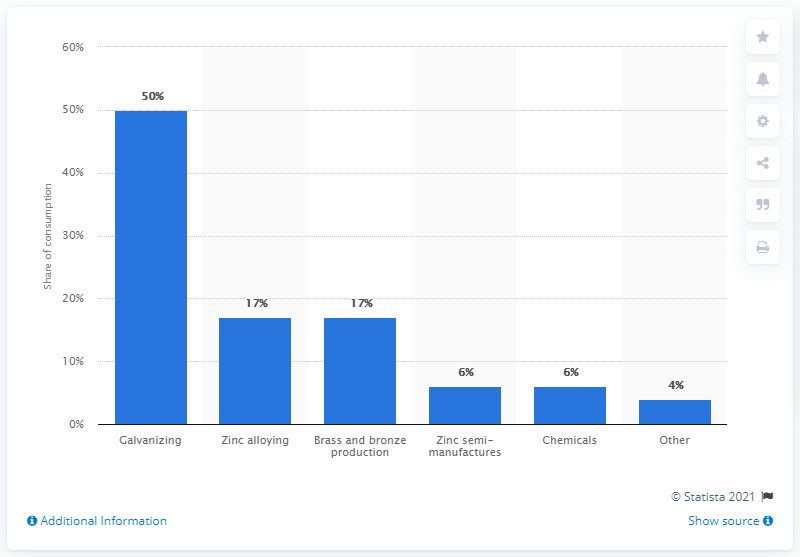Give some essential details in this illustration. The largest end use of zinc worldwide in 2018 was galvanizing. 